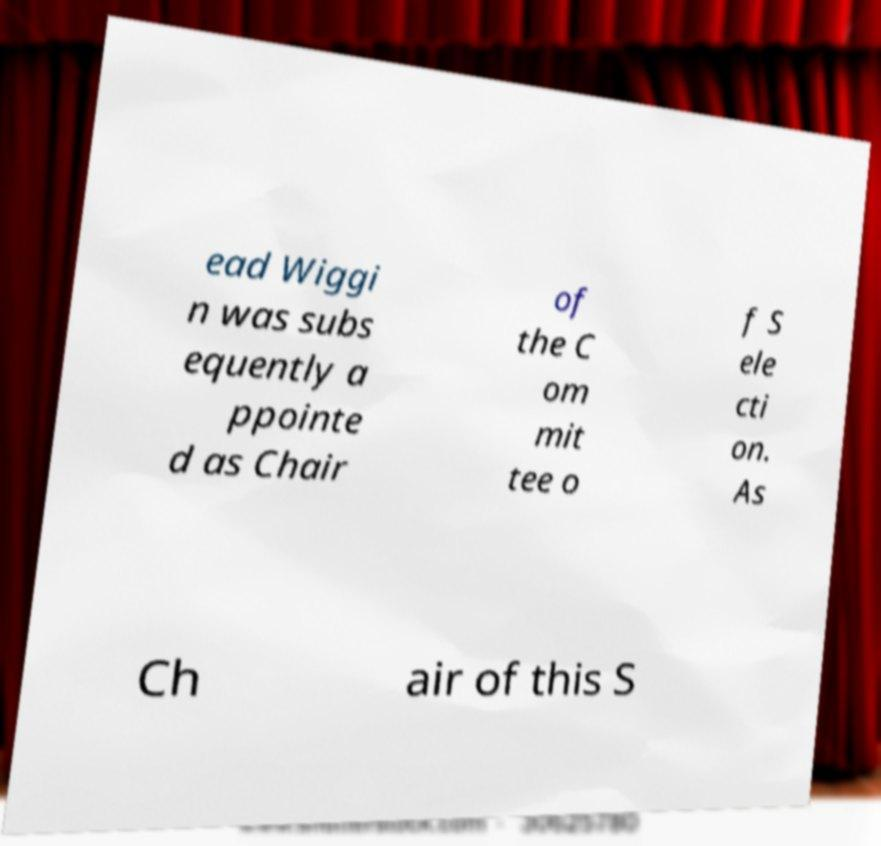Can you accurately transcribe the text from the provided image for me? ead Wiggi n was subs equently a ppointe d as Chair of the C om mit tee o f S ele cti on. As Ch air of this S 